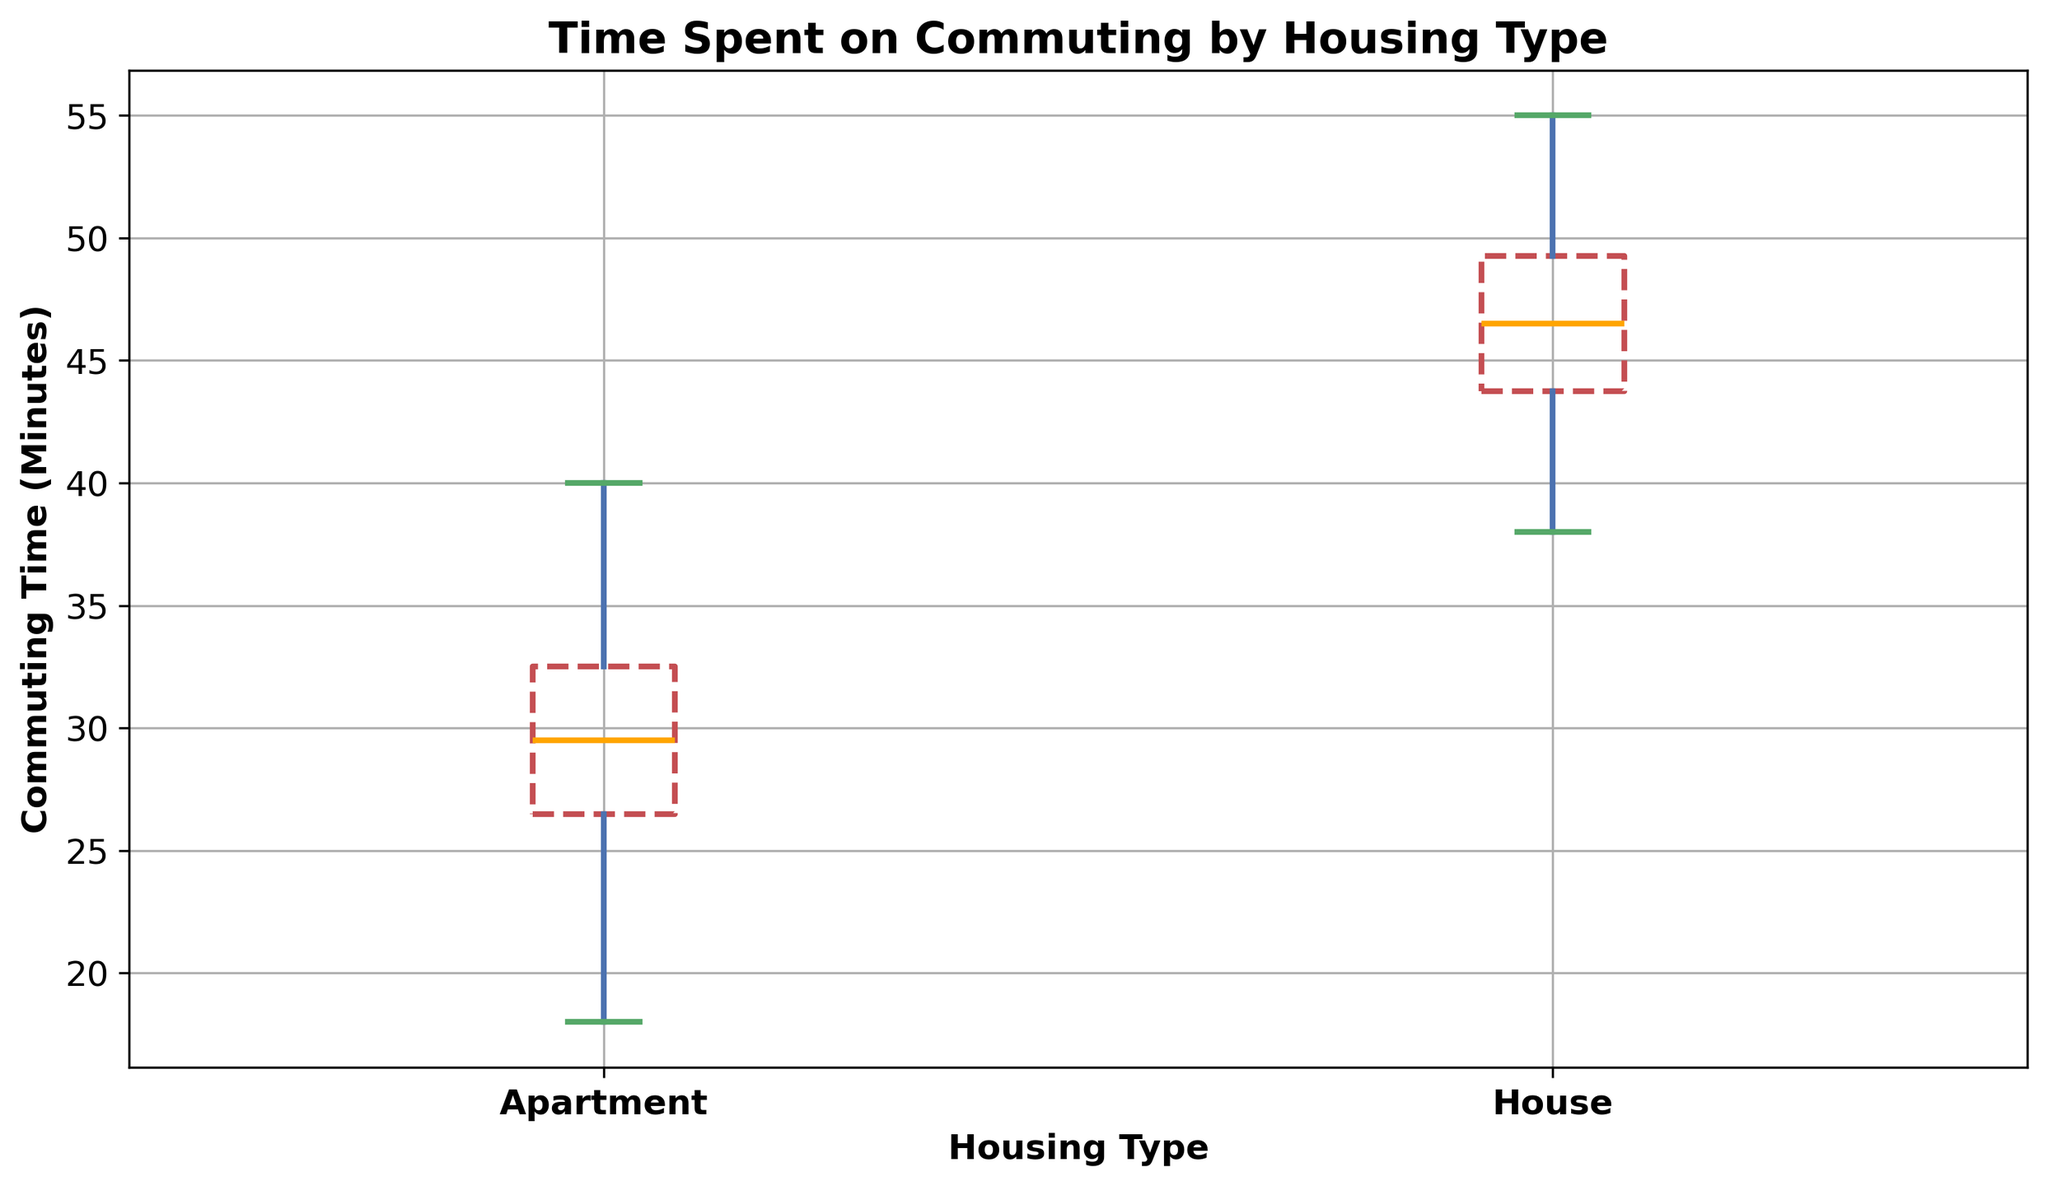What is the median commuting time for people living in apartments? The median commuting time for apartments can be identified by the orange line within the box corresponding to 'Apartment'.
Answer: 29 minutes What is the range of commuting times for people living in houses? The range is calculated by subtracting the minimum value at the lower whisker from the maximum value at the upper whisker in the 'House' category. Let's observe the endpoints of the whiskers.
Answer: 38 minutes to 55 minutes Is the median commuting time higher for people living in houses or apartments? Compare the positions of the orange lines within the boxes for 'House' and 'Apartment'. The one higher up on the y-axis indicates a higher median commuting time.
Answer: Houses How do the interquartile ranges (IQR) of commuting times differ between apartments and houses? The IQR is the range between the lower quartile (bottom of the box) and the upper quartile (top of the box). Compare the height of the boxes for 'Apartment' and 'House'.
Answer: Apartments have a smaller IQR compared to houses Which housing type has more outliers for commuting time and what are they? Outliers are represented by any data points that fall outside the whiskers. Count and list the number and values of such points for 'Apartment' and 'House'.
Answer: Apartments have two outliers: 18 and 40 minutes What's the difference between the median commuting times of houses and apartments? Subtract the median line of 'Apartment' from the median line of 'House'.
Answer: 16 minutes Which housing type has a more consistent commuting time (less variability)? Consistency is generally indicated by a smaller interquartile range (IQR). Compare the height of the boxes again for 'Apartment' and 'House'.
Answer: Apartments What colors are used for the box props in the plot, and what do they represent in terms of commuting time? Look at the box outlines for both housing types and identify the style. The boxes are red with a dashed line, representing the distribution of commuting times.
Answer: Red with dashed lines What can you infer about the commuting times for people living in apartments based on the whiskers and the box plot? Analyze the positions and lengths of the whiskers and the box. The whiskers represent the range without outliers, the ends of the box represent the interquartile range, and the median line shows the central tendency.
Answer: Apartment commuting times mostly range from 22 to 35 minutes with a median of 29 minutes What's the mode (most frequent value) of the commuting times for those living in both housing types, if represented in the plots? The mode is not directly observable in a box plot; thus, go back to the list of values and see which commuting times repeat most frequently for 'Apartment' and 'House'.
Answer: Mode can't be determined from the box plot 